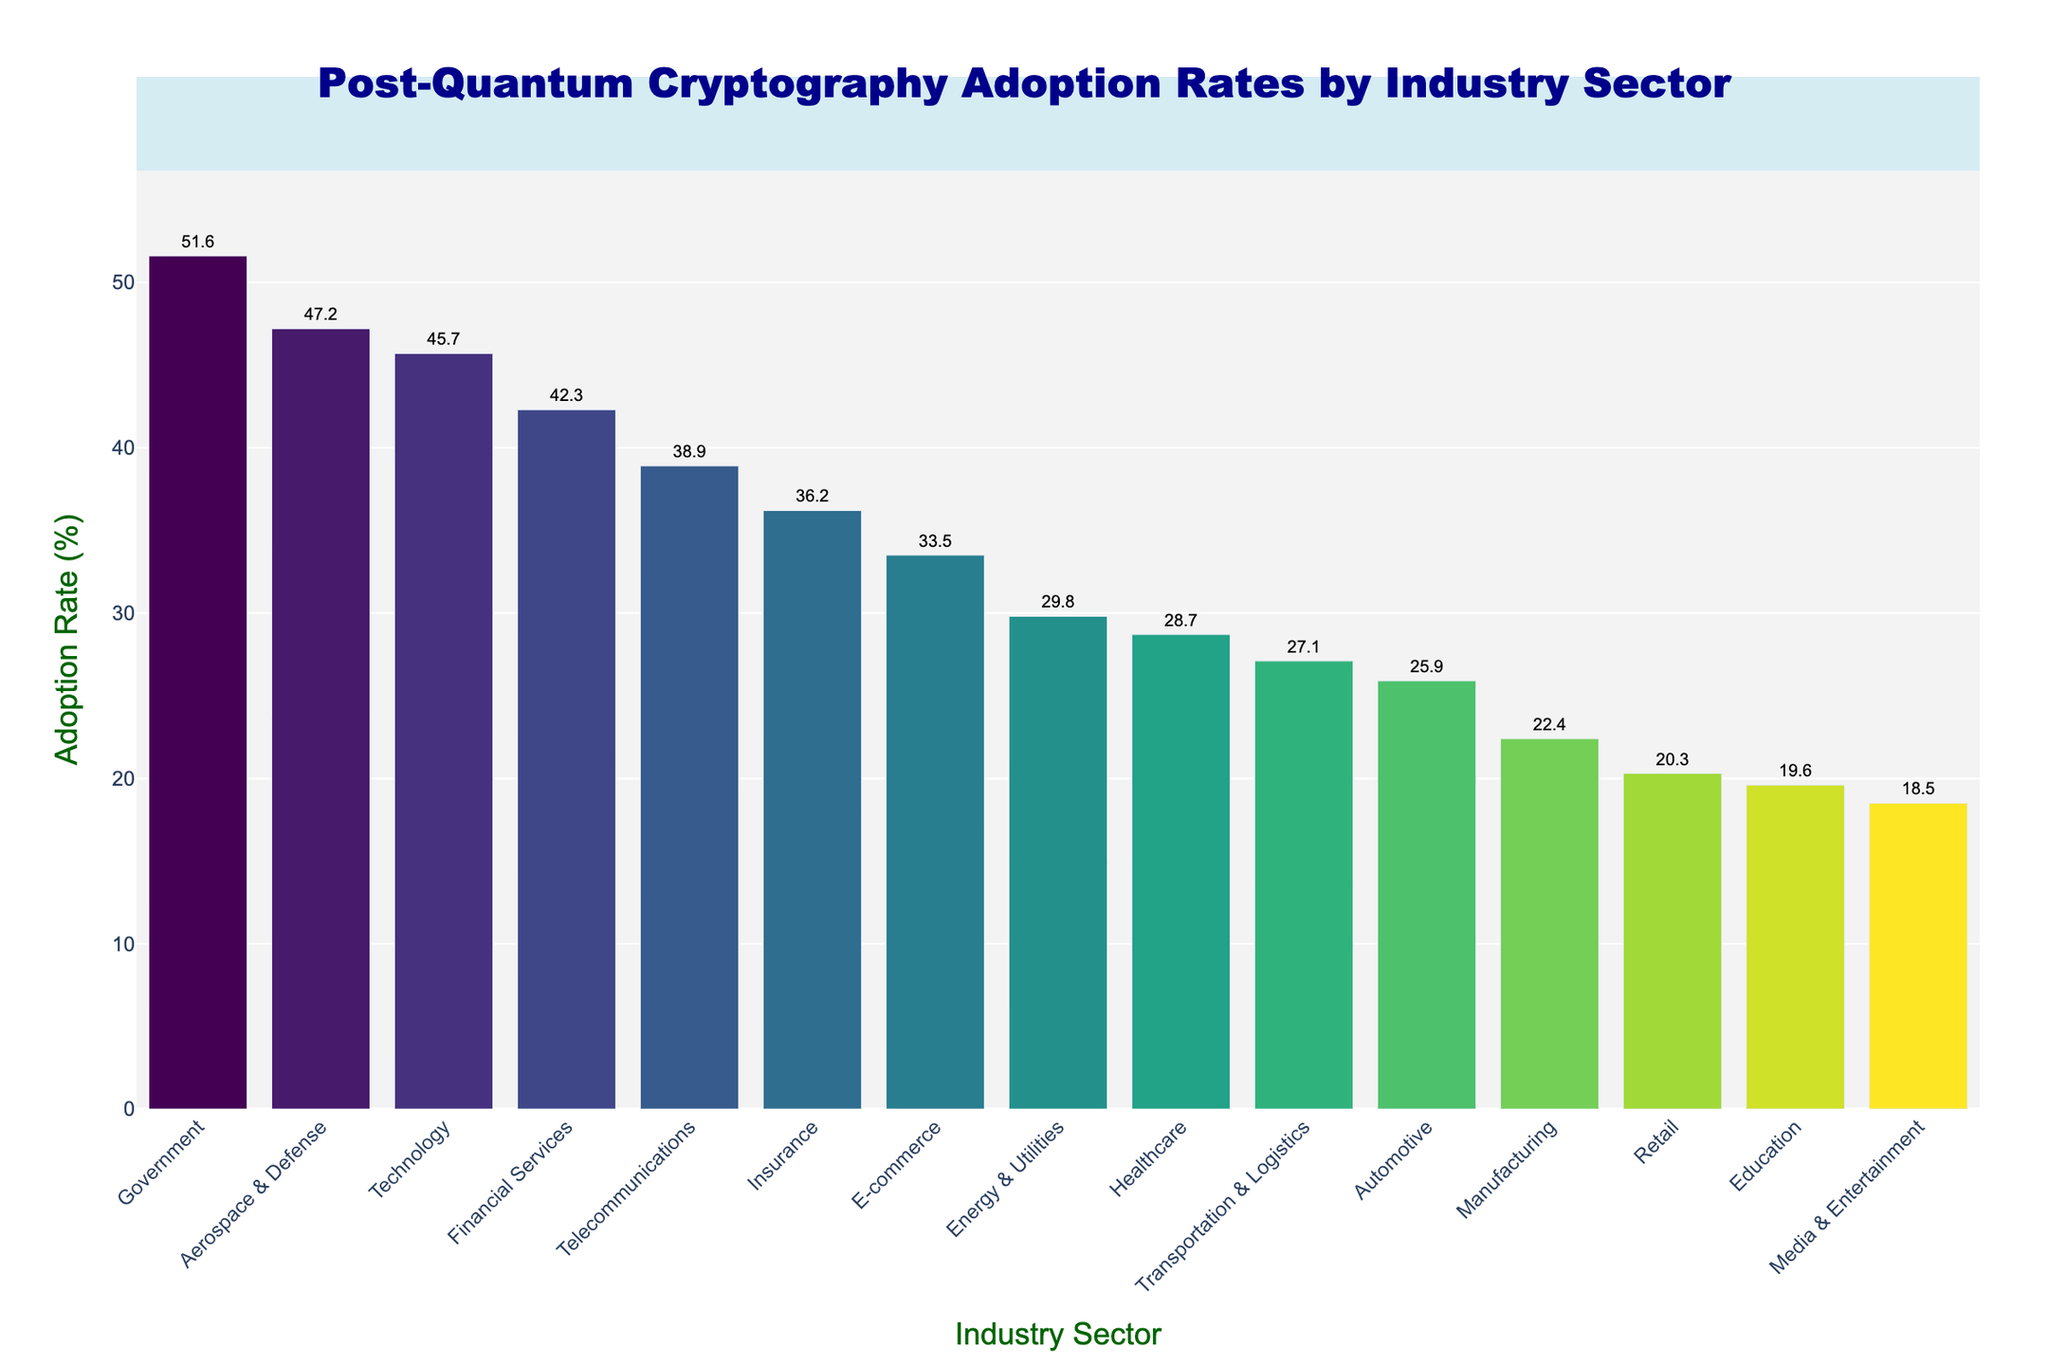What is the adoption rate of post-quantum cryptography algorithms in the Technology sector? Locate the bar corresponding to the Technology sector and read the value indicated at the top of the bar.
Answer: 45.7% What is the difference in adoption rates between the Government and Education sectors? Identify the adoption rates for both Government (51.6%) and Education (19.6%) from the bars, then subtract the smaller value from the larger value: 51.6% - 19.6% = 32.0%.
Answer: 32.0% Which industry sector has the highest adoption rate, and what is it? Find the tallest bar in the chart and read its corresponding label and value. The Government sector has the highest adoption rate at 51.6%.
Answer: Government, 51.6% Compare the adoption rates between the Healthcare and Energy & Utilities sectors. Which one is higher, and by how much? Identify the adoption rates for Healthcare (28.7%) and Energy & Utilities (29.8%) from the bars. The difference is 29.8% - 28.7% = 1.1%. The Energy & Utilities sector is higher.
Answer: Energy & Utilities, 1.1% What is the median adoption rate among all the industry sectors? List the adoption rates in ascending order and find the middle value. If the number of sectors is even, average the two central values. The sorted rates are: 18.5, 19.6, 20.3, 22.4, 25.9, 27.1, 28.7, 29.8, 33.5, 36.2, 38.9, 42.3, 45.7, 47.2, 51.6. The median of these 15 values is the 8th value, which is 29.8%.
Answer: 29.8% How many sectors have an adoption rate above 40%? Count the bars whose values are above 40%. These sectors are Financial Services, Government, Aerospace & Defense, Technology, which makes 4 sectors.
Answer: 4 sectors What is the average adoption rate across all industry sectors? Sum all adoption rates and divide by the number of sectors. Total sum: 42.3 + 28.7 + 51.6 + 38.9 + 47.2 + 33.5 + 29.8 + 22.4 + 19.6 + 45.7 + 36.2 + 25.9 + 20.3 + 27.1 + 18.5 = 488.7. Number of sectors: 15. Average rate: 488.7/15 ≈ 32.6%.
Answer: 32.6% Which industry sector has the lowest adoption rate, and what is it? Find the shortest bar in the chart and read its corresponding label and value. The Media & Entertainment sector has the lowest adoption rate at 18.5%.
Answer: Media & Entertainment, 18.5% Which two adjacent sectors have the smallest difference in their adoption rates? Compare the differences between each pair of adjacent sectors from the sorted list: Financial Services (42.3), Healthcare (28.7), Government (51.6), Telecommunications (38.9), Aerospace & Defense (47.2), E-commerce (33.5), Energy & Utilities (29.8), Manufacturing (22.4), Education (19.6), Technology (45.7), Insurance (36.2), Automotive (25.9), Retail (20.3), Transportation & Logistics (27.1), Media & Entertainment (18.5). The smallest difference is between Retail (20.3) and Education (19.6) with 0.7%.
Answer: Education and Retail, 0.7% 